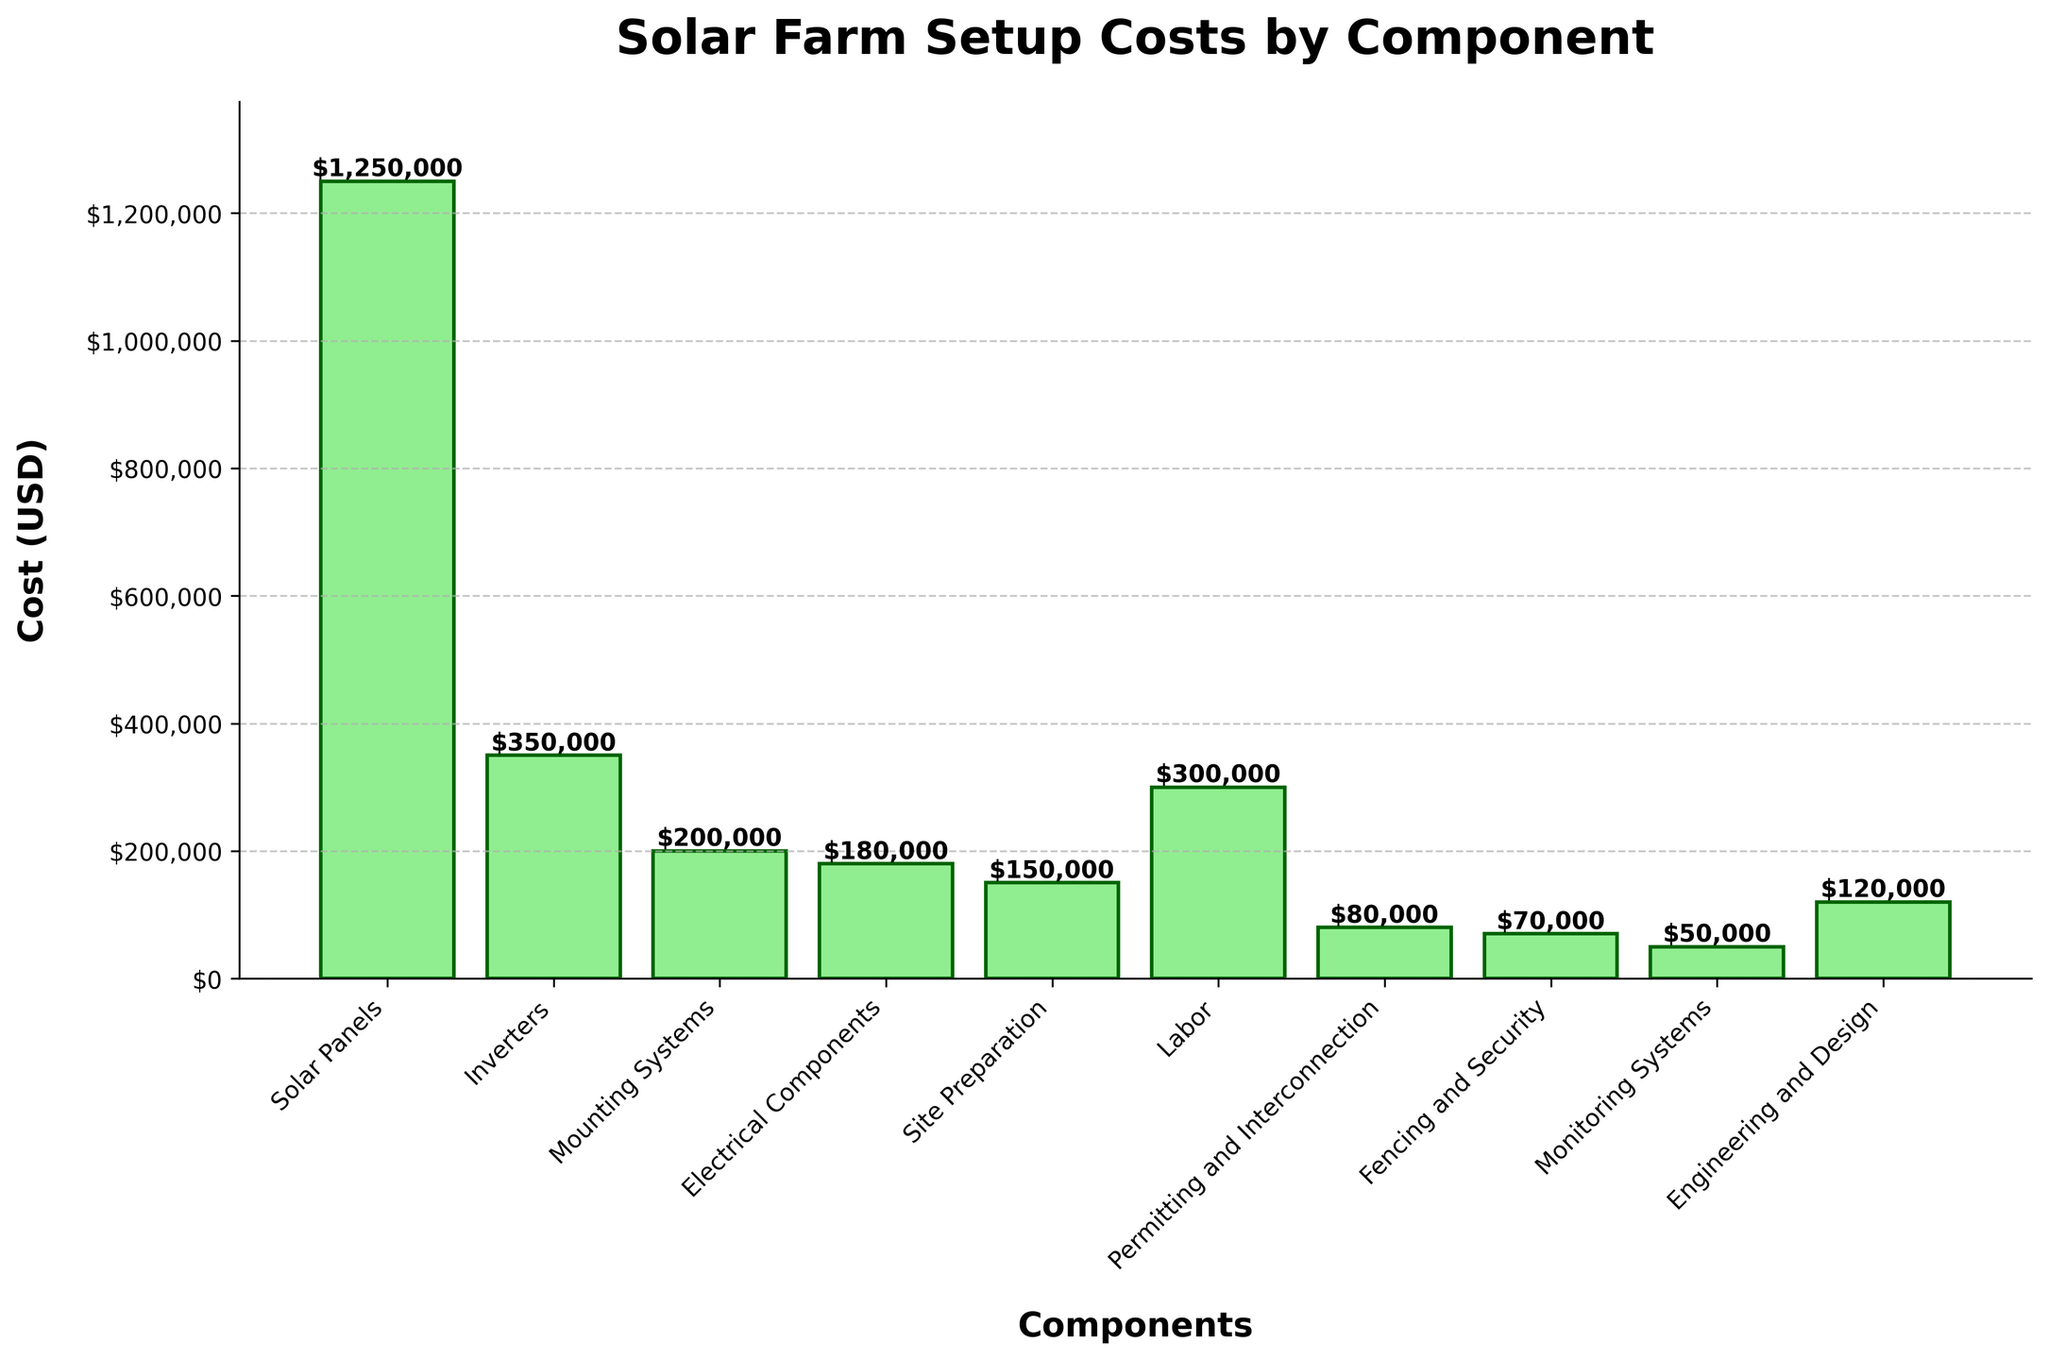How much more expensive are solar panels compared to inverters? First, find the cost of the solar panels ($1,250,000) and the cost of the inverters ($350,000). Subtract the cost of inverters from the cost of solar panels: $1,250,000 - $350,000 = $900,000.
Answer: $900,000 What is the total cost of electrical components and monitoring systems combined? Find the cost of electrical components ($180,000) and monitoring systems ($50,000). Add these two values together: $180,000 + $50,000 = $230,000.
Answer: $230,000 Which component has the lowest initial cost? Look at the heights of all the bars and identify the shortest one. The shortest bar corresponds to monitoring systems, which costs $50,000.
Answer: Monitoring Systems Is the cost of labor more than the cost of mounting systems? Compare the heights of the bars for labor and mounting systems. Labor costs $300,000 and mounting systems cost $200,000.
Answer: Yes What is the average cost of inverters, site preparation, and engineering and design? Find the costs of inverters ($350,000), site preparation ($150,000), and engineering and design ($120,000). Sum these costs and divide by 3: ($350,000 + $150,000 + $120,000) / 3 = $206,667.
Answer: $206,667 By how much does the cost of solar panels exceed the cost of fencing and security? Find the cost of solar panels ($1,250,000) and fencing and security ($70,000). Subtract the latter from the former: $1,250,000 - $70,000 = $1,180,000.
Answer: $1,180,000 What percentage of the total cost does site preparation represent? Sum all the component costs to get the total cost: $1,250,000 + $350,000 + $200,000 + $180,000 + $150,000 + $300,000 + $80,000 + $70,000 + $50,000 + $120,000 = $2,750,000. Then, calculate the percentage: ($150,000 / $2,750,000) * 100 ≈ 5.45%.
Answer: 5.45% What is the cost difference between the most and least expensive components? Identify the most expensive component (solar panels, $1,250,000) and the least expensive component (monitoring systems, $50,000). Subtract the latter from the former: $1,250,000 - $50,000 = $1,200,000.
Answer: $1,200,000 Which two components combined make up the highest cost? Sum the costs of all possible pairs of components and find the highest sum: Solar Panels ($1,250,000) + Inverters ($350,000) = $1,600,000 which is the highest combination.
Answer: Solar Panels and Inverters How does the cost of site preparation compare to the cost of permitting and interconnection? Compare the heights of the bars for site preparation ($150,000) and permitting and interconnection ($80,000).
Answer: Site preparation is more expensive 